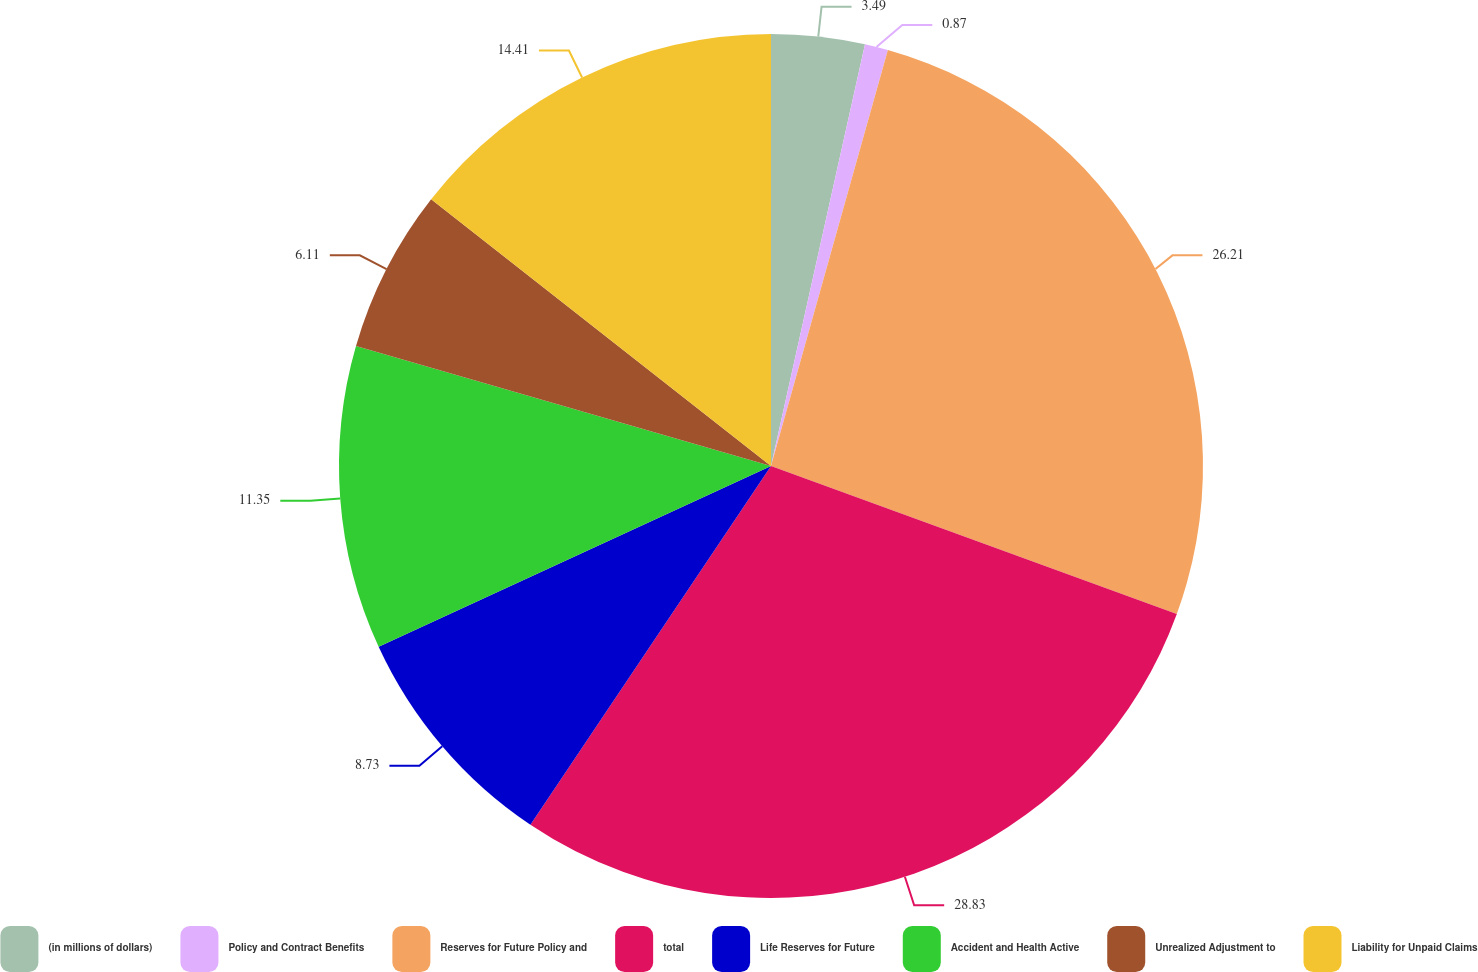Convert chart. <chart><loc_0><loc_0><loc_500><loc_500><pie_chart><fcel>(in millions of dollars)<fcel>Policy and Contract Benefits<fcel>Reserves for Future Policy and<fcel>total<fcel>Life Reserves for Future<fcel>Accident and Health Active<fcel>Unrealized Adjustment to<fcel>Liability for Unpaid Claims<nl><fcel>3.49%<fcel>0.87%<fcel>26.21%<fcel>28.83%<fcel>8.73%<fcel>11.35%<fcel>6.11%<fcel>14.41%<nl></chart> 